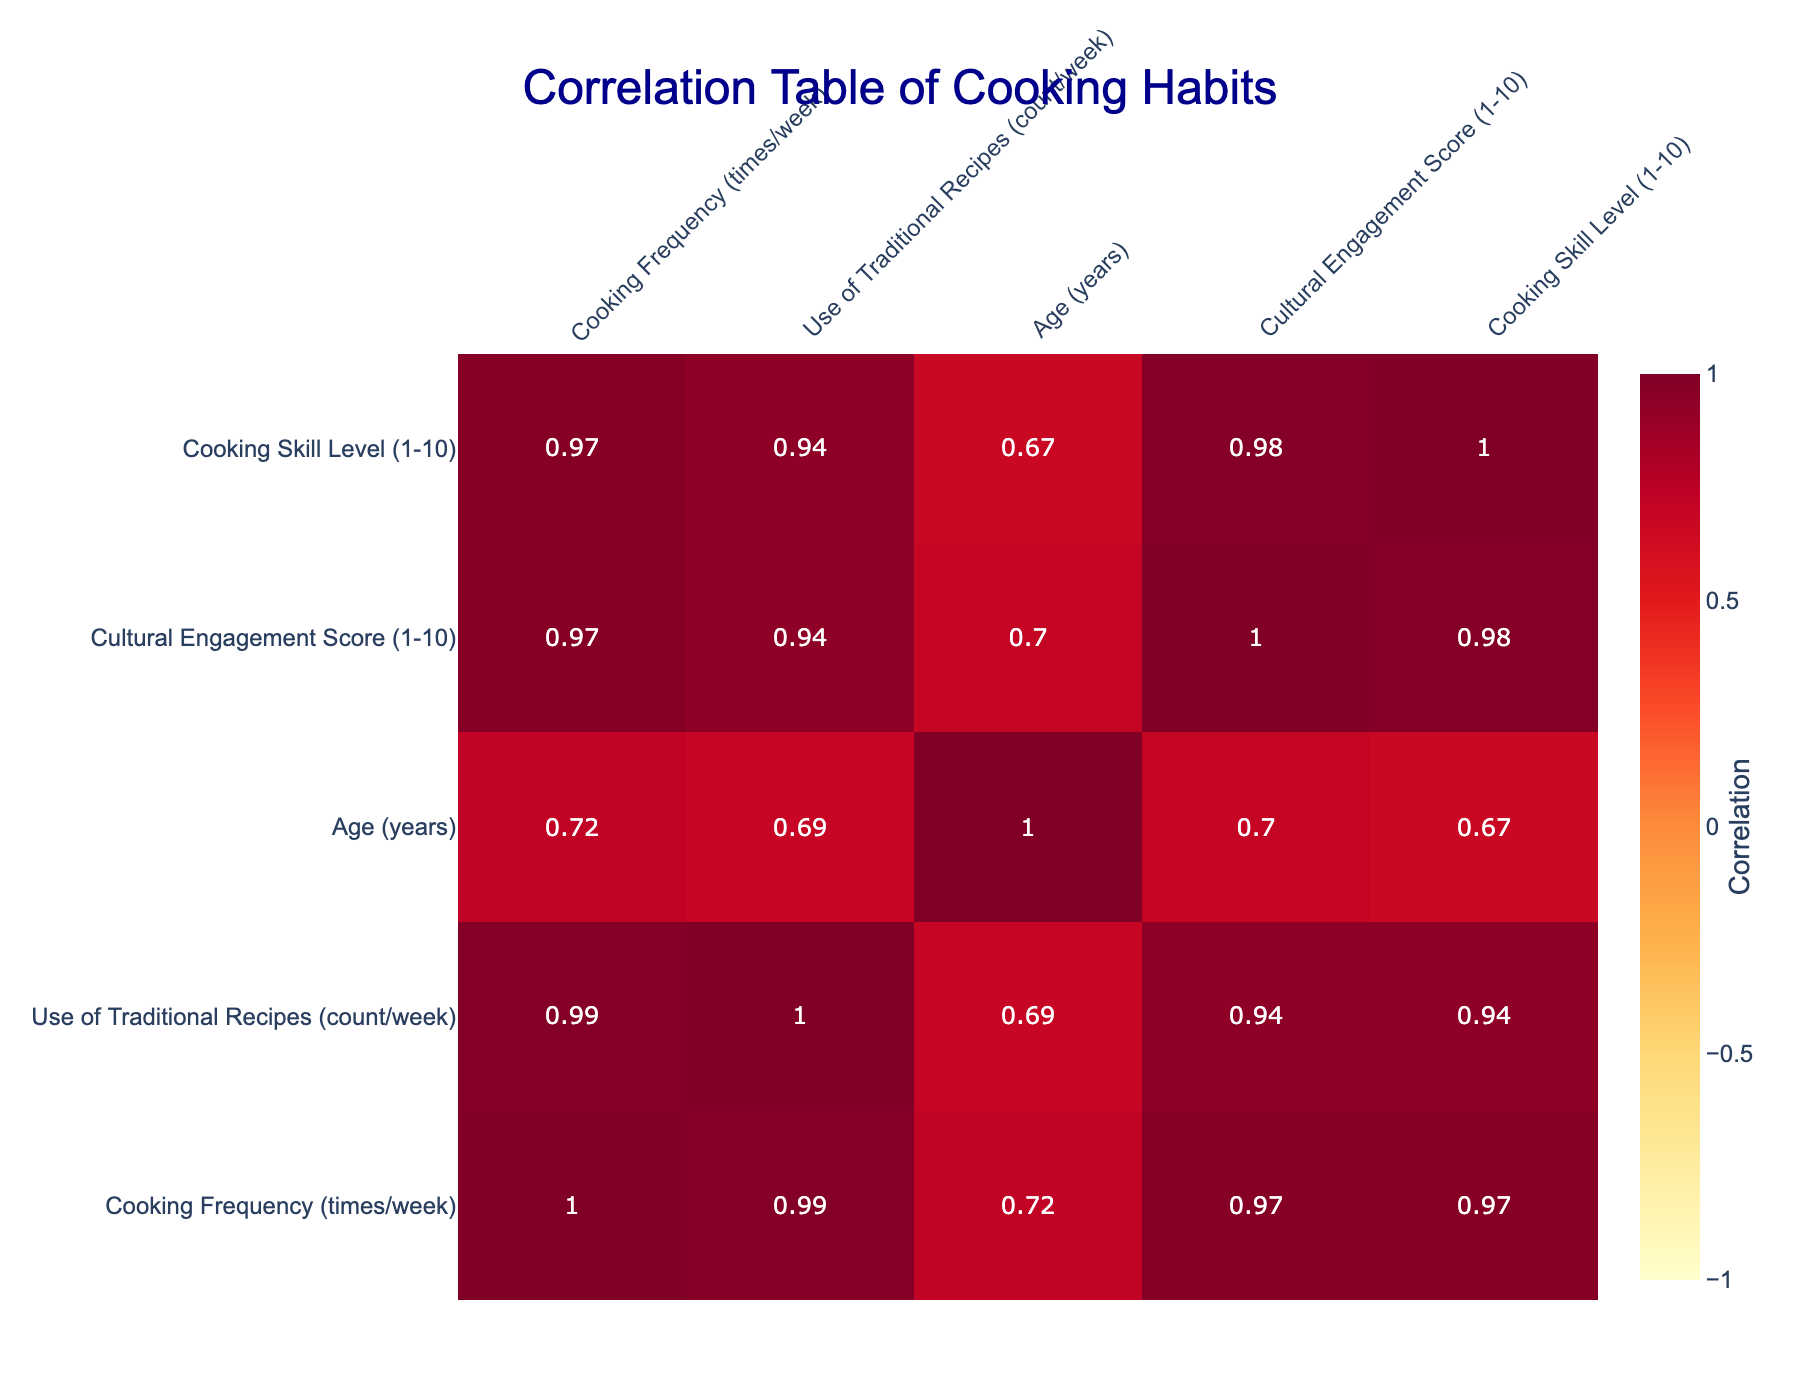What is the correlation between cooking frequency and the use of traditional recipes? The correlation coefficient between cooking frequency and the use of traditional recipes can be found directly in the table. It shows a positive correlation of around 0.83, indicating that as cooking frequency increases, the use of traditional recipes also tends to increase.
Answer: 0.83 Is there a positive correlation between age and the cultural engagement score? By looking at the correlation values, the relationship between age and cultural engagement score is approximately 0.6, which is a moderate positive correlation, suggesting that older individuals tend to have a higher cultural engagement score.
Answer: Yes What is the average cooking frequency among participants who use traditional recipes more than 3 times a week? First, identify the participants using traditional recipes more than 3 times a week: those who use them 4, 5, and 6 times result in 4, 5, and 6 cooking frequencies. Then, sum these frequencies (4 + 5 + 6 = 15) and divide by the number of participants (3), yielding an average of 15 / 3 = 5.
Answer: 5 Is the cooking skill level of participants who cook more frequently always higher than those who cook less frequently? To answer this, assess the cooking skill levels of participants with varying cooking frequencies. For example: the participant cooking 6 times has a skill level of 9, while the one cooking 1 time has a skill level of 2. However, not all participants who cook frequently show higher skill; there are limits, showing that this statement is not universally true.
Answer: No What is the maximum use of traditional recipes by any participant? From the table, the use of traditional recipes varies in their counts. The maximum value is 6, noted for the participant who cooks 6 times per week.
Answer: 6 